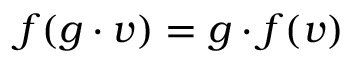<formula> <loc_0><loc_0><loc_500><loc_500>f ( g \cdot v ) = g \cdot f ( v )</formula> 